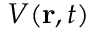Convert formula to latex. <formula><loc_0><loc_0><loc_500><loc_500>V ( r , t )</formula> 